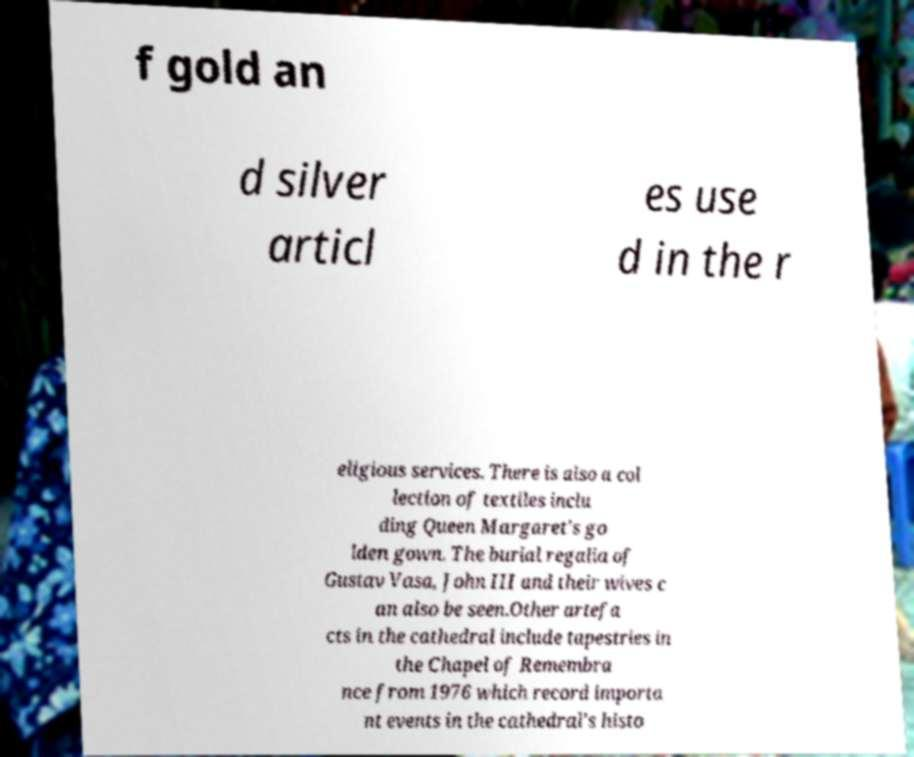There's text embedded in this image that I need extracted. Can you transcribe it verbatim? f gold an d silver articl es use d in the r eligious services. There is also a col lection of textiles inclu ding Queen Margaret's go lden gown. The burial regalia of Gustav Vasa, John III and their wives c an also be seen.Other artefa cts in the cathedral include tapestries in the Chapel of Remembra nce from 1976 which record importa nt events in the cathedral's histo 